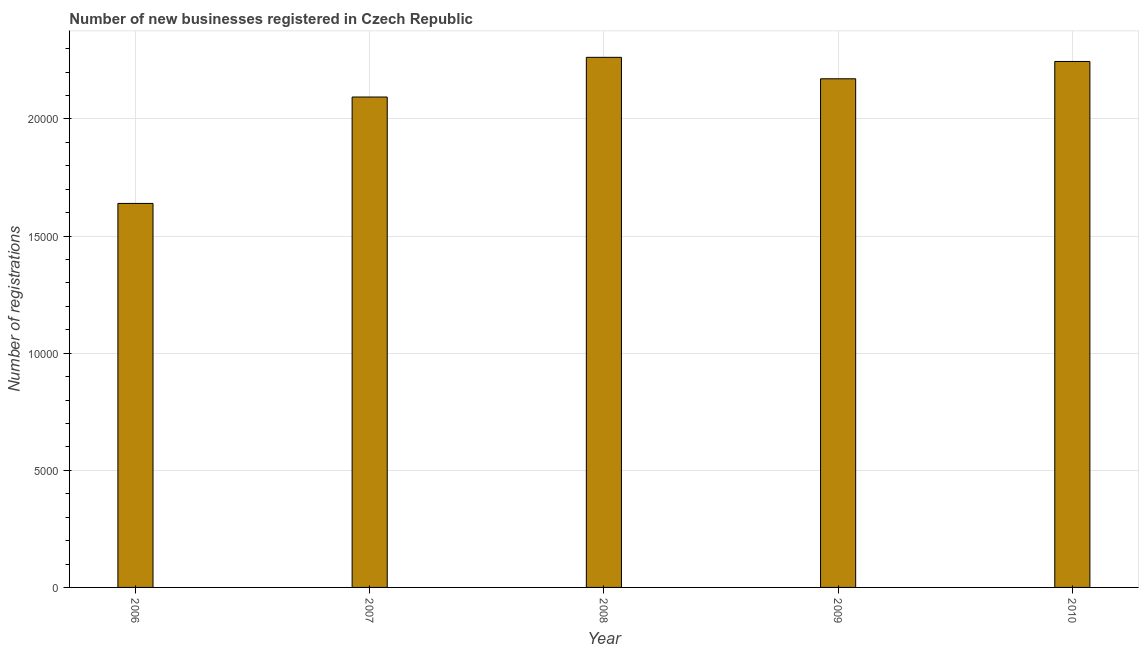Does the graph contain grids?
Your answer should be very brief. Yes. What is the title of the graph?
Offer a terse response. Number of new businesses registered in Czech Republic. What is the label or title of the X-axis?
Make the answer very short. Year. What is the label or title of the Y-axis?
Keep it short and to the point. Number of registrations. What is the number of new business registrations in 2007?
Your answer should be very brief. 2.09e+04. Across all years, what is the maximum number of new business registrations?
Provide a short and direct response. 2.26e+04. Across all years, what is the minimum number of new business registrations?
Make the answer very short. 1.64e+04. In which year was the number of new business registrations maximum?
Offer a terse response. 2008. In which year was the number of new business registrations minimum?
Your answer should be compact. 2006. What is the sum of the number of new business registrations?
Offer a very short reply. 1.04e+05. What is the difference between the number of new business registrations in 2006 and 2008?
Provide a succinct answer. -6238. What is the average number of new business registrations per year?
Offer a terse response. 2.08e+04. What is the median number of new business registrations?
Make the answer very short. 2.17e+04. Do a majority of the years between 2006 and 2007 (inclusive) have number of new business registrations greater than 3000 ?
Keep it short and to the point. Yes. What is the ratio of the number of new business registrations in 2006 to that in 2008?
Your answer should be very brief. 0.72. Is the difference between the number of new business registrations in 2008 and 2009 greater than the difference between any two years?
Your answer should be very brief. No. What is the difference between the highest and the second highest number of new business registrations?
Keep it short and to the point. 177. Is the sum of the number of new business registrations in 2006 and 2009 greater than the maximum number of new business registrations across all years?
Your answer should be compact. Yes. What is the difference between the highest and the lowest number of new business registrations?
Offer a terse response. 6238. In how many years, is the number of new business registrations greater than the average number of new business registrations taken over all years?
Your answer should be very brief. 4. Are all the bars in the graph horizontal?
Offer a very short reply. No. How many years are there in the graph?
Your answer should be compact. 5. What is the difference between two consecutive major ticks on the Y-axis?
Offer a terse response. 5000. What is the Number of registrations of 2006?
Your answer should be very brief. 1.64e+04. What is the Number of registrations of 2007?
Keep it short and to the point. 2.09e+04. What is the Number of registrations of 2008?
Offer a terse response. 2.26e+04. What is the Number of registrations of 2009?
Provide a succinct answer. 2.17e+04. What is the Number of registrations in 2010?
Your answer should be compact. 2.25e+04. What is the difference between the Number of registrations in 2006 and 2007?
Provide a short and direct response. -4543. What is the difference between the Number of registrations in 2006 and 2008?
Ensure brevity in your answer.  -6238. What is the difference between the Number of registrations in 2006 and 2009?
Give a very brief answer. -5322. What is the difference between the Number of registrations in 2006 and 2010?
Make the answer very short. -6061. What is the difference between the Number of registrations in 2007 and 2008?
Provide a succinct answer. -1695. What is the difference between the Number of registrations in 2007 and 2009?
Offer a terse response. -779. What is the difference between the Number of registrations in 2007 and 2010?
Your response must be concise. -1518. What is the difference between the Number of registrations in 2008 and 2009?
Your response must be concise. 916. What is the difference between the Number of registrations in 2008 and 2010?
Keep it short and to the point. 177. What is the difference between the Number of registrations in 2009 and 2010?
Keep it short and to the point. -739. What is the ratio of the Number of registrations in 2006 to that in 2007?
Your answer should be very brief. 0.78. What is the ratio of the Number of registrations in 2006 to that in 2008?
Your answer should be compact. 0.72. What is the ratio of the Number of registrations in 2006 to that in 2009?
Offer a very short reply. 0.76. What is the ratio of the Number of registrations in 2006 to that in 2010?
Offer a very short reply. 0.73. What is the ratio of the Number of registrations in 2007 to that in 2008?
Keep it short and to the point. 0.93. What is the ratio of the Number of registrations in 2007 to that in 2009?
Keep it short and to the point. 0.96. What is the ratio of the Number of registrations in 2007 to that in 2010?
Ensure brevity in your answer.  0.93. What is the ratio of the Number of registrations in 2008 to that in 2009?
Your answer should be very brief. 1.04. 